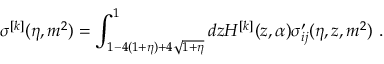Convert formula to latex. <formula><loc_0><loc_0><loc_500><loc_500>\sigma ^ { [ k ] } ( \eta , m ^ { 2 } ) = \int _ { 1 - 4 ( 1 + \eta ) + 4 \sqrt { 1 + \eta } } ^ { 1 } d z H ^ { [ k ] } ( z , \alpha ) \sigma _ { i j } ^ { \prime } ( \eta , z , m ^ { 2 } ) \ .</formula> 